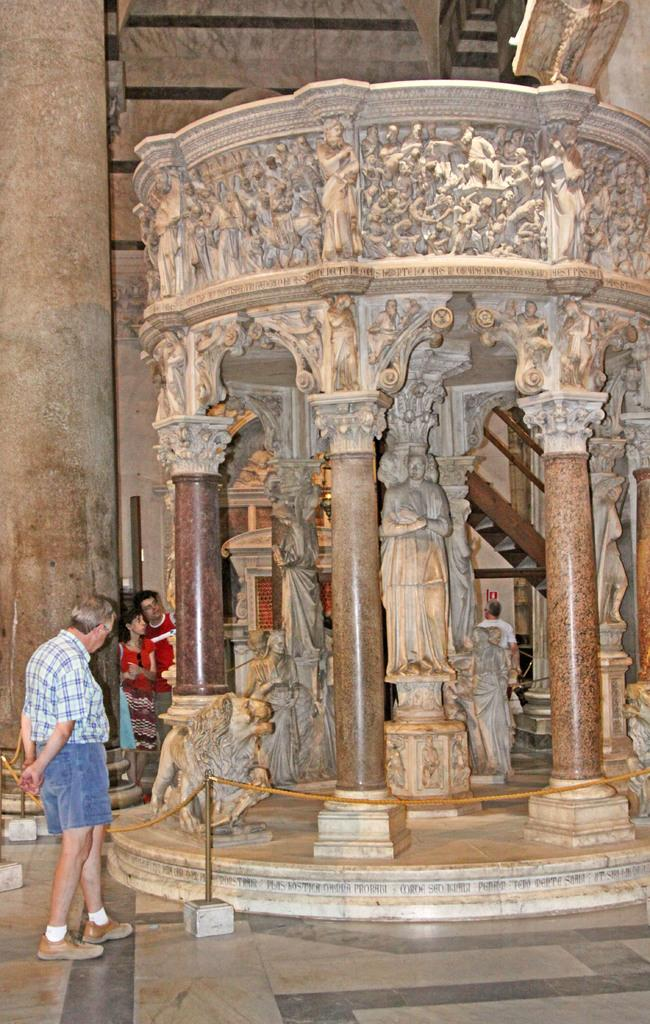What are the people in the image doing? The persons standing on the floor in the image are likely observing or interacting with the surrounding environment. What type of objects can be seen in the image that might serve as a barrier or guide? Barrier poles are present in the image. What type of artistic elements can be seen in the image? Statues and sculptures are present in the image. Can you describe any architectural features in the image? There is a staircase, railings, and pillars visible in the image. How much iron is present in the image? There is no specific mention of iron in the image, so it is not possible to determine the amount of iron present. 